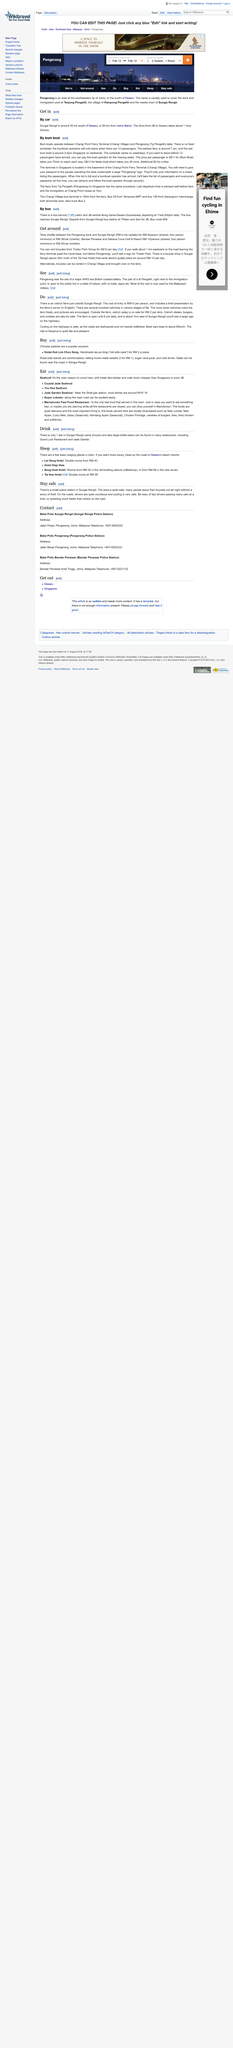List a handful of essential elements in this visual. Yes, people can engage in both cycling and visiting an ostrich farm as activities. There are several hundred ostriches on the ostrich farm. It will cost RM 9 per person to travel by taxi between the Pengerang dock and Sungai Rengit, with a shared minimum of four people. It is noted that bicycle rental at Tristan Park Group will cost S$10 per day, for those opting to travel by bicycle. The entrance fee to the ostrich farm is RM15 per person. 